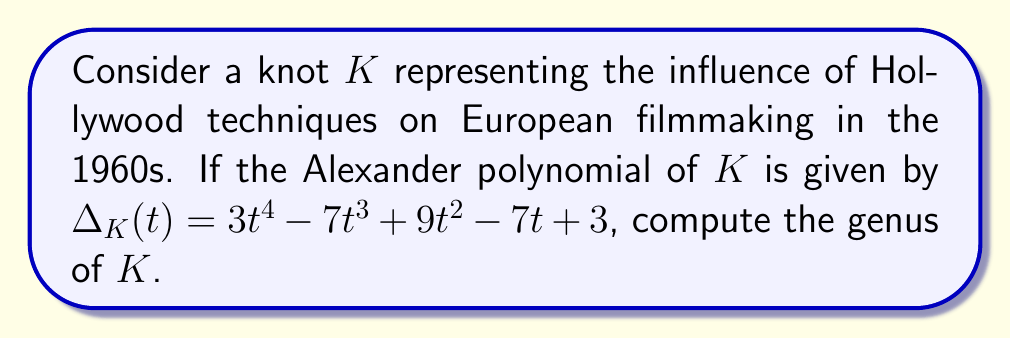Provide a solution to this math problem. To compute the genus of the knot $K$, we can use the relationship between the Alexander polynomial and the genus. The steps are as follows:

1) Recall that for any knot $K$, the degree of its Alexander polynomial $\Delta_K(t)$ is always less than or equal to twice the genus of $K$. Mathematically, this is expressed as:

   $$\deg(\Delta_K(t)) \leq 2g(K)$$

   where $g(K)$ is the genus of the knot $K$.

2) In this case, the Alexander polynomial is:

   $$\Delta_K(t) = 3t^4 - 7t^3 + 9t^2 - 7t + 3$$

3) The degree of this polynomial is 4.

4) Therefore, we can write:

   $$4 \leq 2g(K)$$

5) Solving for $g(K)$:

   $$g(K) \geq \frac{4}{2} = 2$$

6) Since the genus must be an integer, and it's the smallest integer satisfying this inequality, we conclude:

   $$g(K) = 2$$

This result symbolizes that the influence of Hollywood techniques on European filmmaking in the 1960s was significant but not overwhelmingly dominant, allowing for a balanced integration of styles.
Answer: $2$ 